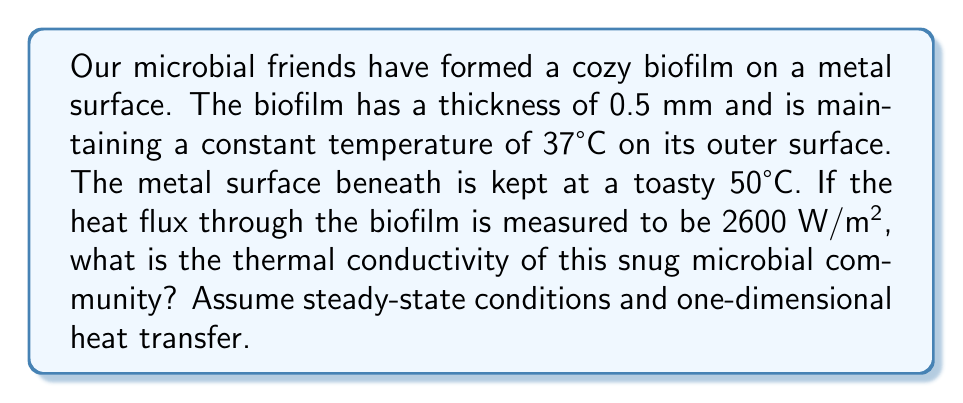What is the answer to this math problem? Let's help our tiny bacterial buddies solve this problem step-by-step:

1) The heat equation for steady-state, one-dimensional heat conduction is:

   $$q = -k \frac{dT}{dx}$$

   Where $q$ is heat flux, $k$ is thermal conductivity, and $\frac{dT}{dx}$ is the temperature gradient.

2) In our cozy biofilm home, the temperature difference is:
   $$\Delta T = T_{hot} - T_{cold} = 50°C - 37°C = 13°C$$

3) The thickness of our microbial mat is 0.5 mm = 0.0005 m

4) We can rewrite our heat equation for a finite thickness:

   $$q = k \frac{\Delta T}{\Delta x}$$

5) Now, let's rearrange to solve for $k$:

   $$k = q \frac{\Delta x}{\Delta T}$$

6) Plugging in our values:

   $$k = 2600 \frac{W}{m^2} \cdot \frac{0.0005 m}{13°C}$$

7) Calculating:

   $$k = 0.1 \frac{W}{m \cdot °C}$$

Our microbial friends have created a biofilm with this thermal conductivity!
Answer: $0.1 \frac{W}{m \cdot °C}$ 